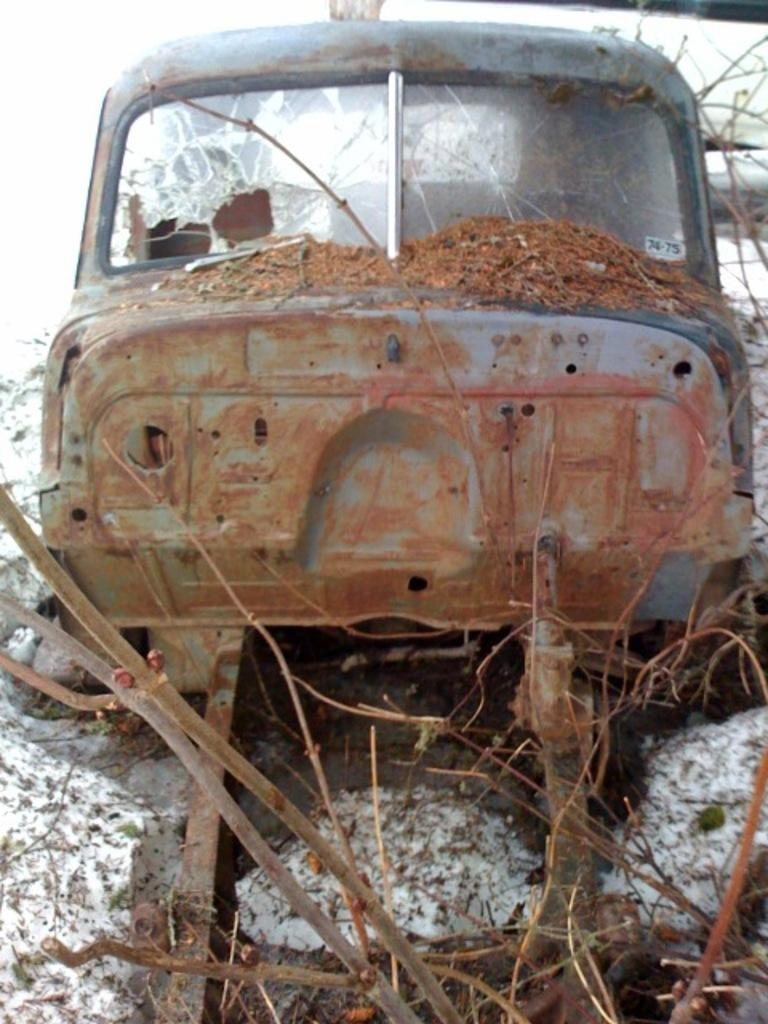What is the condition of the car in the image? The car in the image appears to be damaged. What evidence supports the idea that the car is damaged? There are broken glass pieces visible in the image. How might the car be classified based on its condition? The car may be considered scrap based on its damaged state. What type of natural elements can be seen in the image? There are branches visible in the image. Can you describe the possible context of the image? The image may depict a slow-motion scene, given the focus on the damaged car and broken glass. What type of oatmeal is being served in the image? There is no oatmeal present in the image; it focuses on a damaged car and broken glass. What time of day does the image depict, given the presence of night? The image does not depict a specific time of day, and there is no mention of night in the provided facts. 